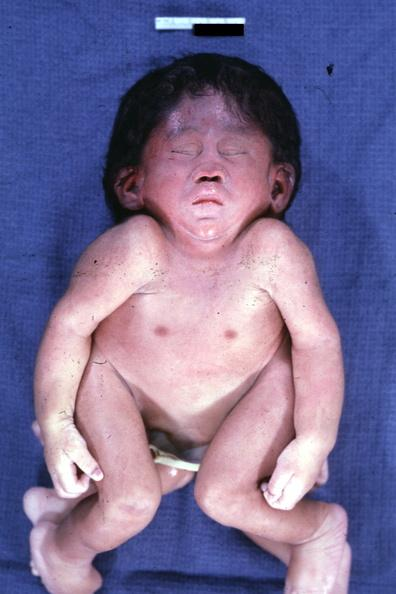does this image show conjoined twins at head and chest?
Answer the question using a single word or phrase. Yes 